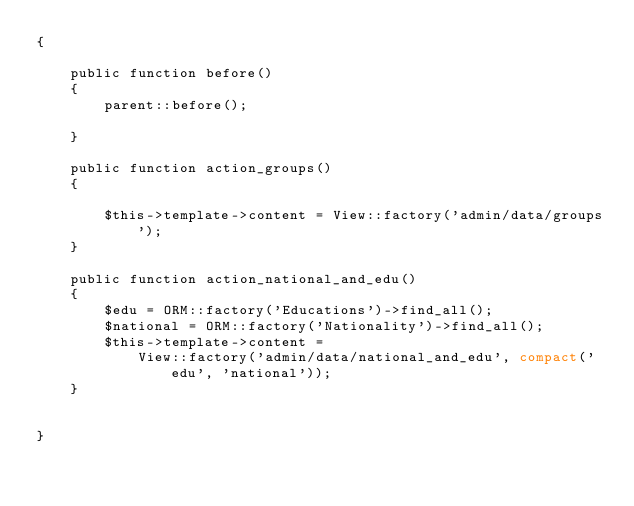Convert code to text. <code><loc_0><loc_0><loc_500><loc_500><_PHP_>{

    public function before()
    {
        parent::before();

    }

    public function action_groups()
    {

        $this->template->content = View::factory('admin/data/groups');
    }

    public function action_national_and_edu()
    {
        $edu = ORM::factory('Educations')->find_all();
        $national = ORM::factory('Nationality')->find_all();
        $this->template->content =
            View::factory('admin/data/national_and_edu', compact('edu', 'national'));
    }


}</code> 